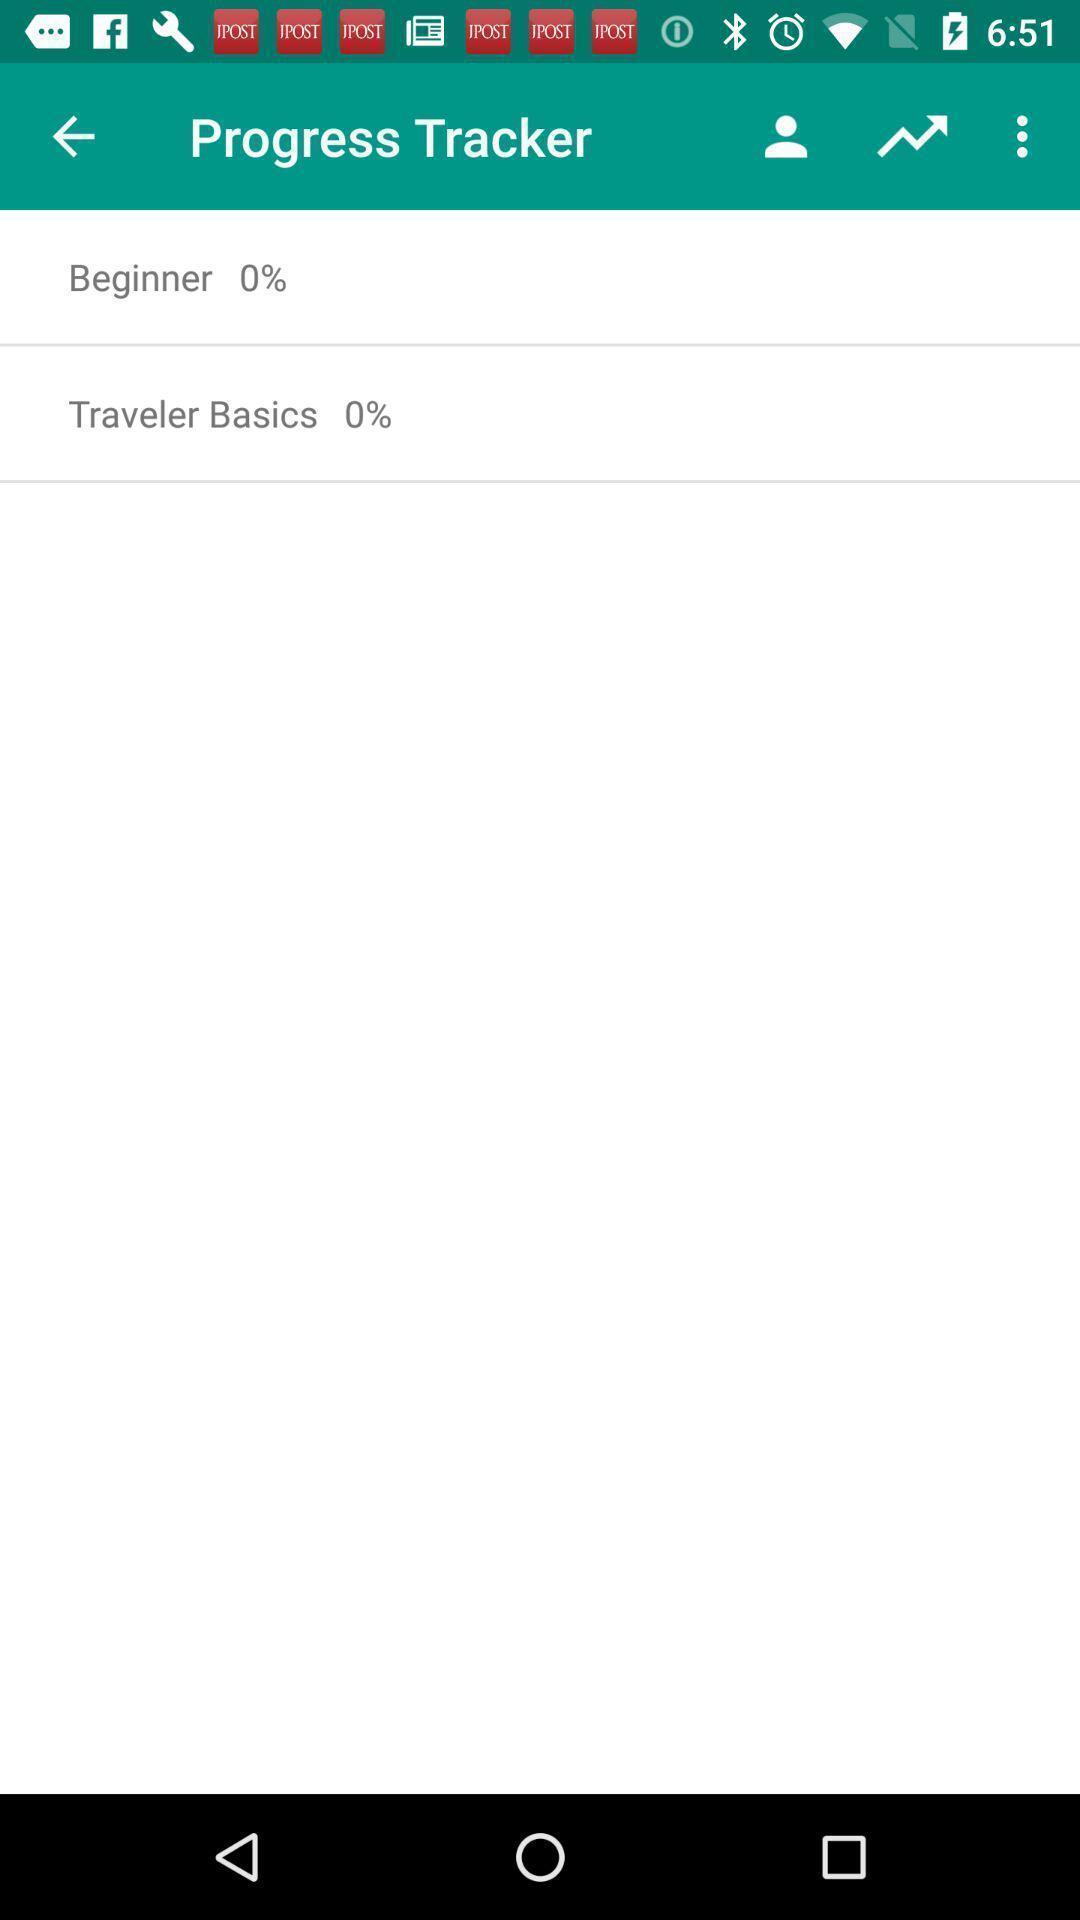Tell me about the visual elements in this screen capture. Two categories showing zero result in the tracking app. 